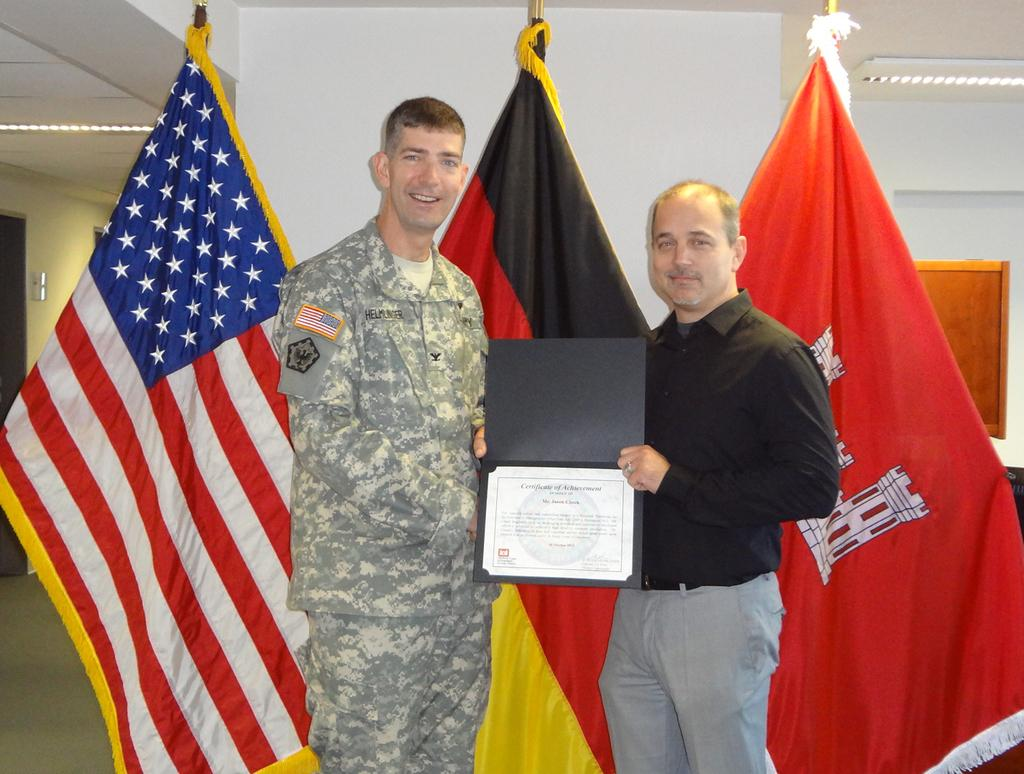<image>
Render a clear and concise summary of the photo. The award the two men are holding with the words certificate of achievement written on it. 